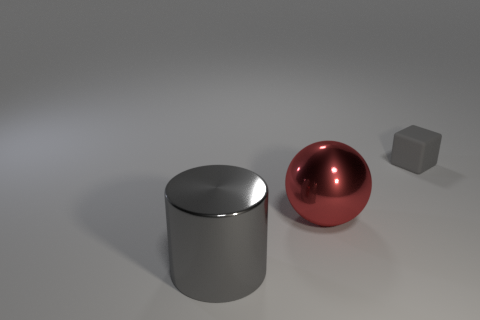Are there an equal number of gray blocks that are left of the big gray metallic object and small rubber objects that are in front of the large shiny ball?
Your response must be concise. Yes. There is a large thing that is the same color as the block; what is its shape?
Provide a succinct answer. Cylinder. There is a large thing that is behind the large gray object; does it have the same color as the metal thing that is in front of the ball?
Your answer should be very brief. No. Is the number of small gray matte blocks in front of the gray shiny cylinder greater than the number of large metallic objects?
Your response must be concise. No. What material is the big red sphere?
Offer a terse response. Metal. There is a big red object that is the same material as the big gray cylinder; what shape is it?
Keep it short and to the point. Sphere. There is a object to the right of the large thing behind the large gray object; what size is it?
Offer a very short reply. Small. There is a shiny thing in front of the red shiny sphere; what is its color?
Provide a short and direct response. Gray. Are there any other small things that have the same shape as the rubber thing?
Your answer should be very brief. No. Is the number of big red metallic balls that are to the left of the big gray metal cylinder less than the number of cylinders behind the shiny ball?
Your answer should be very brief. No. 